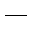Convert formula to latex. <formula><loc_0><loc_0><loc_500><loc_500>\_</formula> 